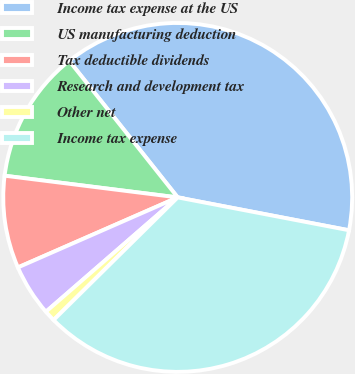Convert chart. <chart><loc_0><loc_0><loc_500><loc_500><pie_chart><fcel>Income tax expense at the US<fcel>US manufacturing deduction<fcel>Tax deductible dividends<fcel>Research and development tax<fcel>Other net<fcel>Income tax expense<nl><fcel>38.7%<fcel>12.33%<fcel>8.56%<fcel>4.8%<fcel>1.03%<fcel>34.58%<nl></chart> 